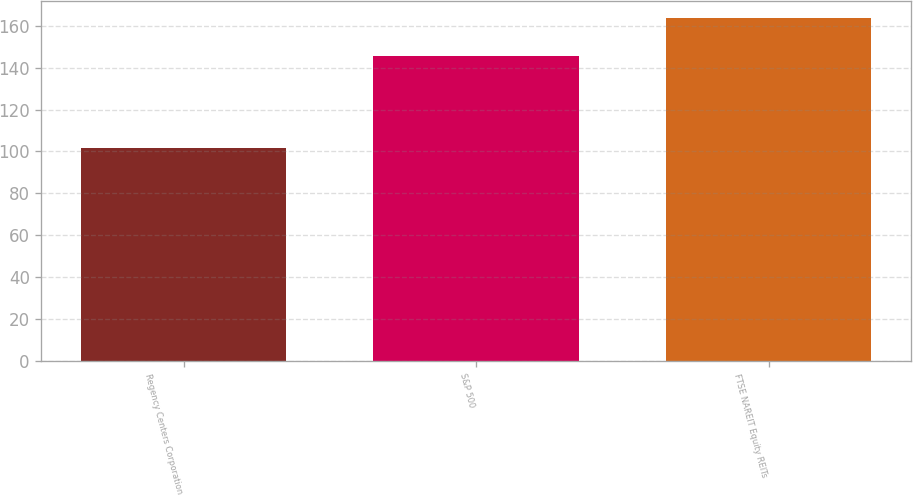Convert chart to OTSL. <chart><loc_0><loc_0><loc_500><loc_500><bar_chart><fcel>Regency Centers Corporation<fcel>S&P 500<fcel>FTSE NAREIT Equity REITs<nl><fcel>101.6<fcel>145.51<fcel>163.78<nl></chart> 